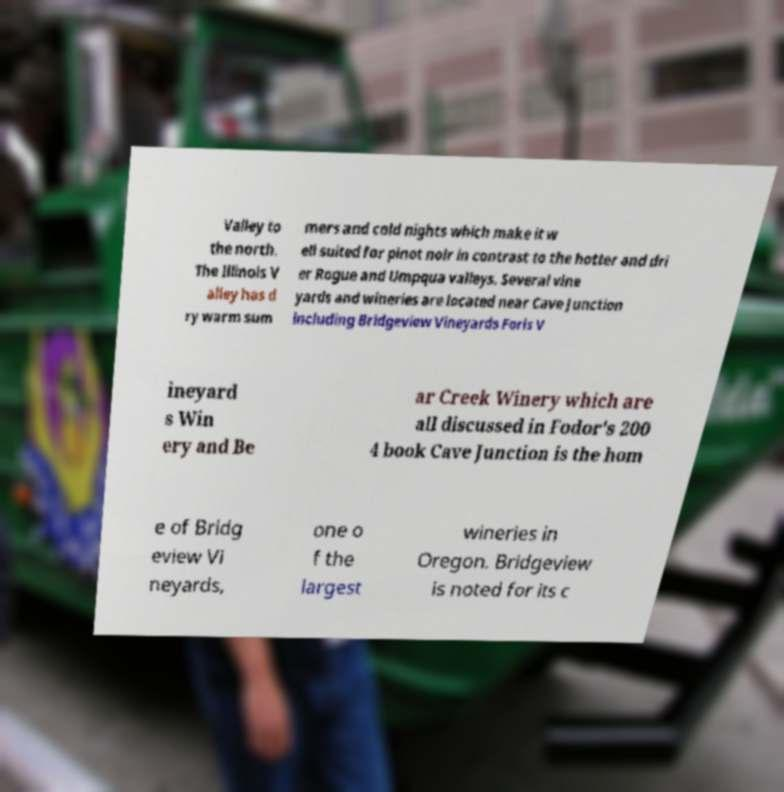Can you read and provide the text displayed in the image?This photo seems to have some interesting text. Can you extract and type it out for me? Valley to the north. The Illinois V alley has d ry warm sum mers and cold nights which make it w ell suited for pinot noir in contrast to the hotter and dri er Rogue and Umpqua valleys. Several vine yards and wineries are located near Cave Junction including Bridgeview Vineyards Foris V ineyard s Win ery and Be ar Creek Winery which are all discussed in Fodor's 200 4 book Cave Junction is the hom e of Bridg eview Vi neyards, one o f the largest wineries in Oregon. Bridgeview is noted for its c 